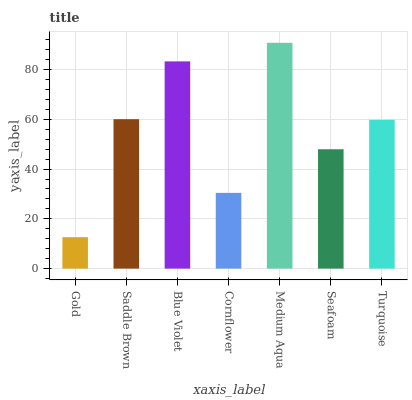Is Gold the minimum?
Answer yes or no. Yes. Is Medium Aqua the maximum?
Answer yes or no. Yes. Is Saddle Brown the minimum?
Answer yes or no. No. Is Saddle Brown the maximum?
Answer yes or no. No. Is Saddle Brown greater than Gold?
Answer yes or no. Yes. Is Gold less than Saddle Brown?
Answer yes or no. Yes. Is Gold greater than Saddle Brown?
Answer yes or no. No. Is Saddle Brown less than Gold?
Answer yes or no. No. Is Turquoise the high median?
Answer yes or no. Yes. Is Turquoise the low median?
Answer yes or no. Yes. Is Saddle Brown the high median?
Answer yes or no. No. Is Gold the low median?
Answer yes or no. No. 